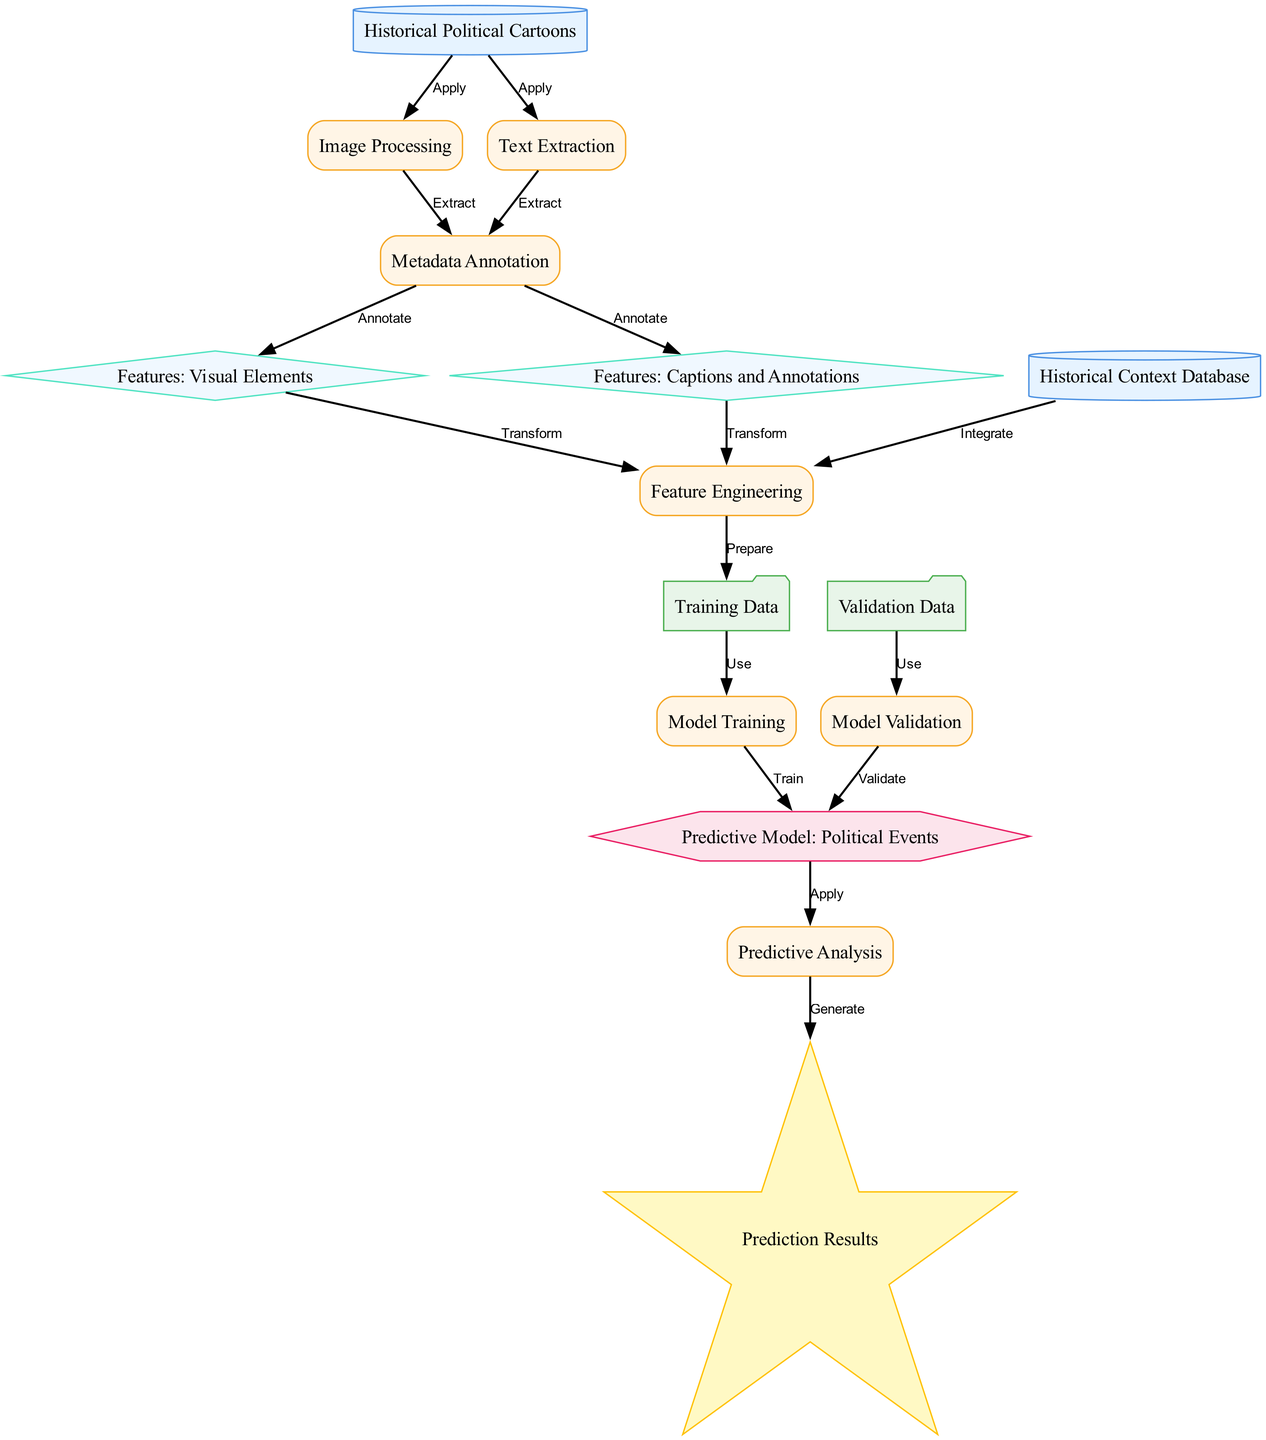What is the primary data source used in this diagram? The primary data source is defined in node "1" labeled as "Historical Political Cartoons," which indicates it serves as the foundational dataset for the predictive modeling process.
Answer: Historical Political Cartoons How many processes are depicted in the diagram? The diagram includes processes that are represented by rectangles. Counting these nodes, there are seven processes: Image Processing, Text Extraction, Metadata Annotation, Feature Engineering, Model Training, Predictive Analysis, and Model Validation.
Answer: Seven What type of node is "Predictive Model: Political Events"? "Predictive Model: Political Events" is identified as a model node in the diagram, specifically indicated by its hexagonal shape representing the output of the model training process.
Answer: Model What connects "Model Training" to "Training Data"? There is an edge labeled "Use" that indicates the connection from "Training Data" to "Model Training," showing that the training data is utilized during the model training phase.
Answer: Use What is the final output of the predictive analysis? The final output, which is represented in node "13," is labeled as "Prediction Results," demonstrating what the model generates after performing predictive analysis.
Answer: Prediction Results How are "Features: Visual Elements" and "Features: Captions and Annotations" related to "Feature Engineering"? Both features are connected to "Feature Engineering" through edges labeled "Transform," indicating that transformations of these features are necessary to create the inputs for the model.
Answer: Transform What type of node is "Historical Context Database"? The "Historical Context Database" is categorized as a data source node, indicated by its cylindrical shape which is characteristic of nodes representing data inputs in the diagram.
Answer: Data Source Which process follows "Feature Engineering"? Following "Feature Engineering," there is the "Training Data" node, which is prepared as a result of the feature engineering process before it moves to model training.
Answer: Training Data 